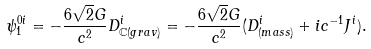<formula> <loc_0><loc_0><loc_500><loc_500>\psi _ { 1 } ^ { 0 i } = - \frac { 6 \sqrt { 2 } G } { c ^ { 2 } } D _ { \mathbb { C } ( g r a v ) } ^ { i } = - \frac { 6 \sqrt { 2 } G } { c ^ { 2 } } ( D _ { ( m a s s ) } ^ { i } + i c ^ { - 1 } J ^ { i } ) .</formula> 